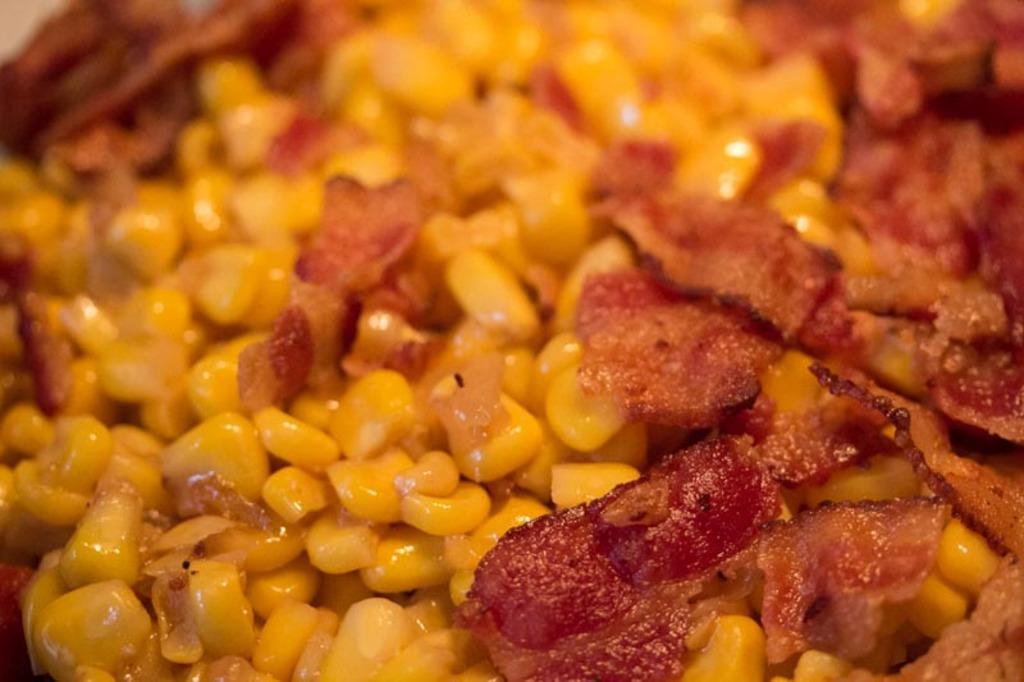How would you summarize this image in a sentence or two? In this image, we can see food. 